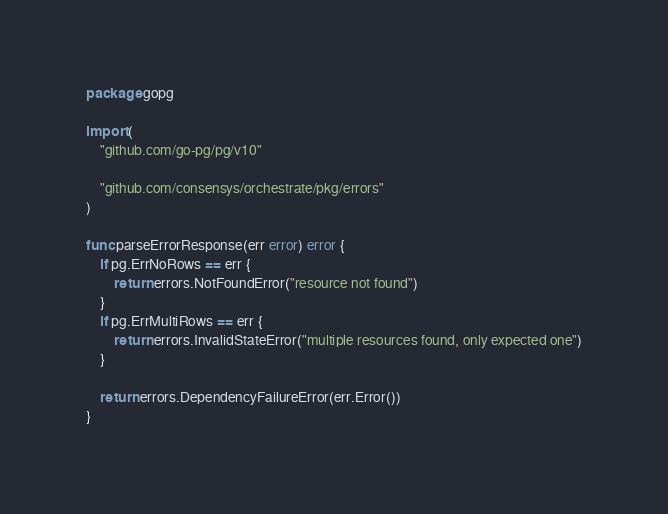<code> <loc_0><loc_0><loc_500><loc_500><_Go_>package gopg

import (
	"github.com/go-pg/pg/v10"

	"github.com/consensys/orchestrate/pkg/errors"
)

func parseErrorResponse(err error) error {
	if pg.ErrNoRows == err {
		return errors.NotFoundError("resource not found")
	}
	if pg.ErrMultiRows == err {
		return errors.InvalidStateError("multiple resources found, only expected one")
	}

	return errors.DependencyFailureError(err.Error())
}
</code> 